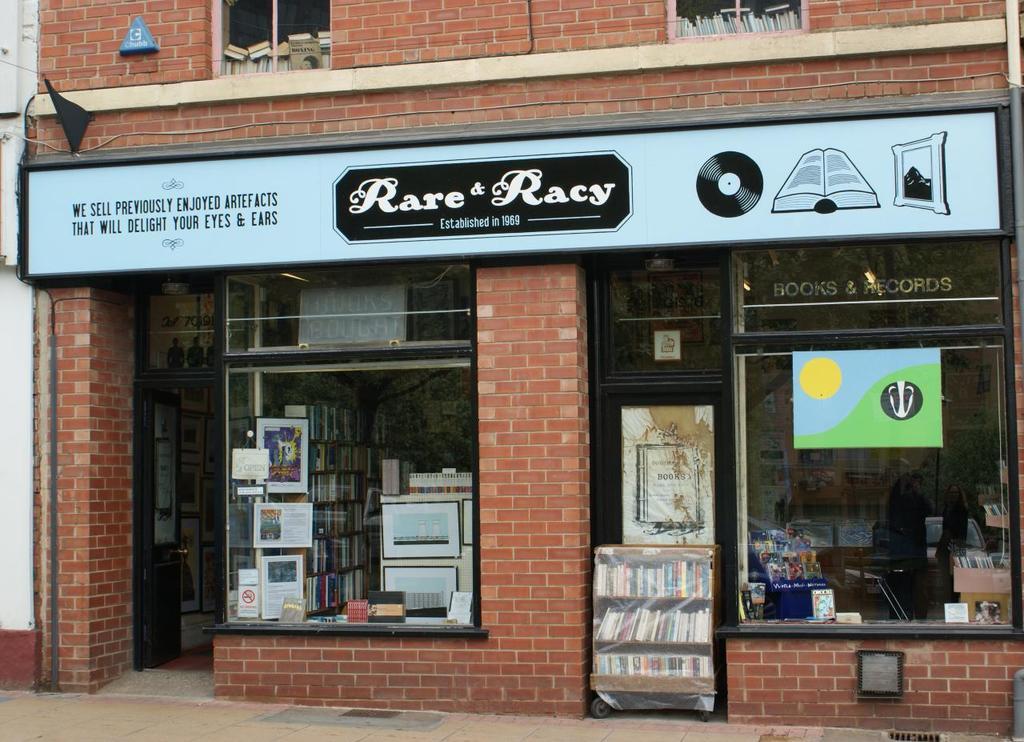What is the name of the store?
Provide a succinct answer. Rare & racy. What is the name of the store?
Provide a succinct answer. Rare & racy. 